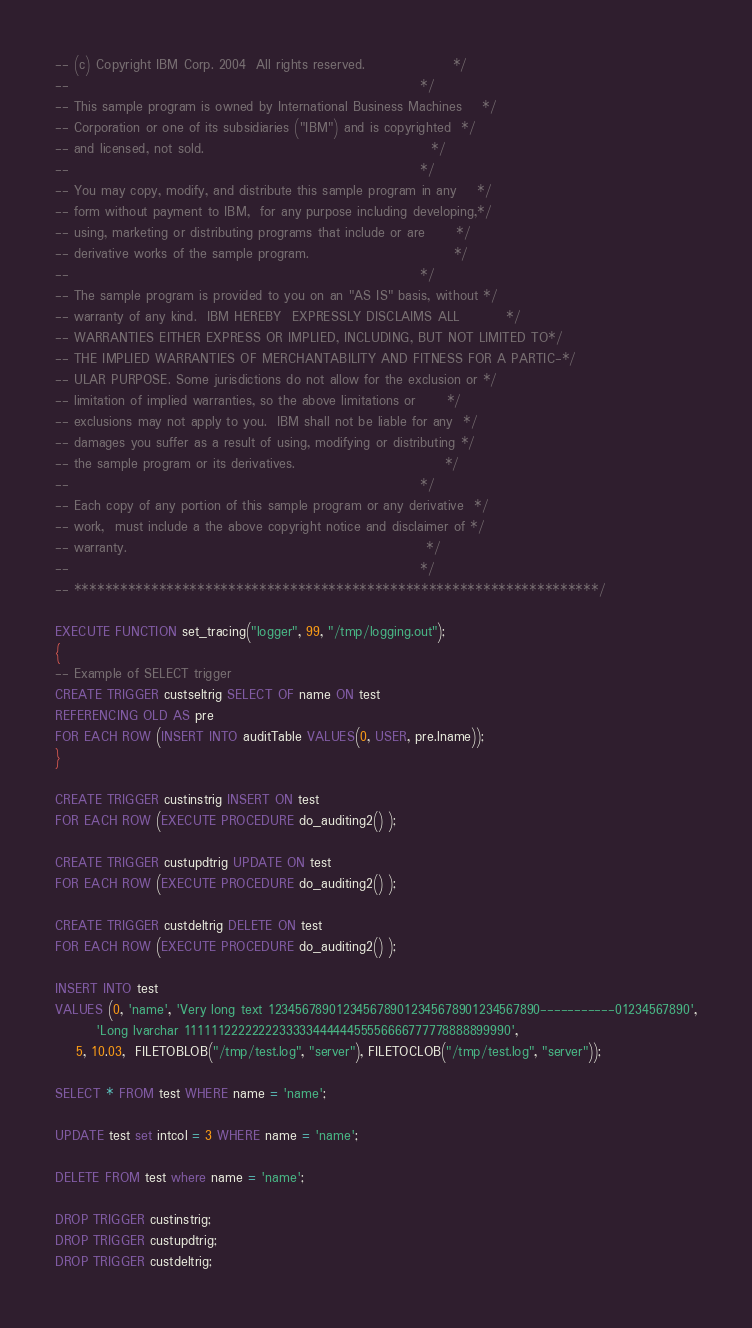Convert code to text. <code><loc_0><loc_0><loc_500><loc_500><_SQL_>-- (c) Copyright IBM Corp. 2004  All rights reserved.                 */
--                                                                    */
-- This sample program is owned by International Business Machines    */
-- Corporation or one of its subsidiaries ("IBM") and is copyrighted  */
-- and licensed, not sold.                                            */
--                                                                    */
-- You may copy, modify, and distribute this sample program in any    */
-- form without payment to IBM,  for any purpose including developing,*/
-- using, marketing or distributing programs that include or are      */
-- derivative works of the sample program.                            */
--                                                                    */
-- The sample program is provided to you on an "AS IS" basis, without */
-- warranty of any kind.  IBM HEREBY  EXPRESSLY DISCLAIMS ALL         */
-- WARRANTIES EITHER EXPRESS OR IMPLIED, INCLUDING, BUT NOT LIMITED TO*/
-- THE IMPLIED WARRANTIES OF MERCHANTABILITY AND FITNESS FOR A PARTIC-*/
-- ULAR PURPOSE. Some jurisdictions do not allow for the exclusion or */
-- limitation of implied warranties, so the above limitations or      */
-- exclusions may not apply to you.  IBM shall not be liable for any  */
-- damages you suffer as a result of using, modifying or distributing */
-- the sample program or its derivatives.                             */
--                                                                    */
-- Each copy of any portion of this sample program or any derivative  */
-- work,  must include a the above copyright notice and disclaimer of */
-- warranty.                                                          */
--                                                                    */
-- ********************************************************************/

EXECUTE FUNCTION set_tracing("logger", 99, "/tmp/logging.out");
{
-- Example of SELECT trigger
CREATE TRIGGER custseltrig SELECT OF name ON test 
REFERENCING OLD AS pre
FOR EACH ROW (INSERT INTO auditTable VALUES(0, USER, pre.lname));
}

CREATE TRIGGER custinstrig INSERT ON test 
FOR EACH ROW (EXECUTE PROCEDURE do_auditing2() );

CREATE TRIGGER custupdtrig UPDATE ON test 
FOR EACH ROW (EXECUTE PROCEDURE do_auditing2() );

CREATE TRIGGER custdeltrig DELETE ON test 
FOR EACH ROW (EXECUTE PROCEDURE do_auditing2() );

INSERT INTO test  
VALUES (0, 'name', 'Very long text 1234567890123456789012345678901234567890-----------01234567890',
        'Long lvarchar 111111222222223333344444455556666777778888899990',
	5, 10.03,  FILETOBLOB("/tmp/test.log", "server"), FILETOCLOB("/tmp/test.log", "server"));

SELECT * FROM test WHERE name = 'name';

UPDATE test set intcol = 3 WHERE name = 'name';

DELETE FROM test where name = 'name'; 

DROP TRIGGER custinstrig;
DROP TRIGGER custupdtrig;
DROP TRIGGER custdeltrig;
</code> 